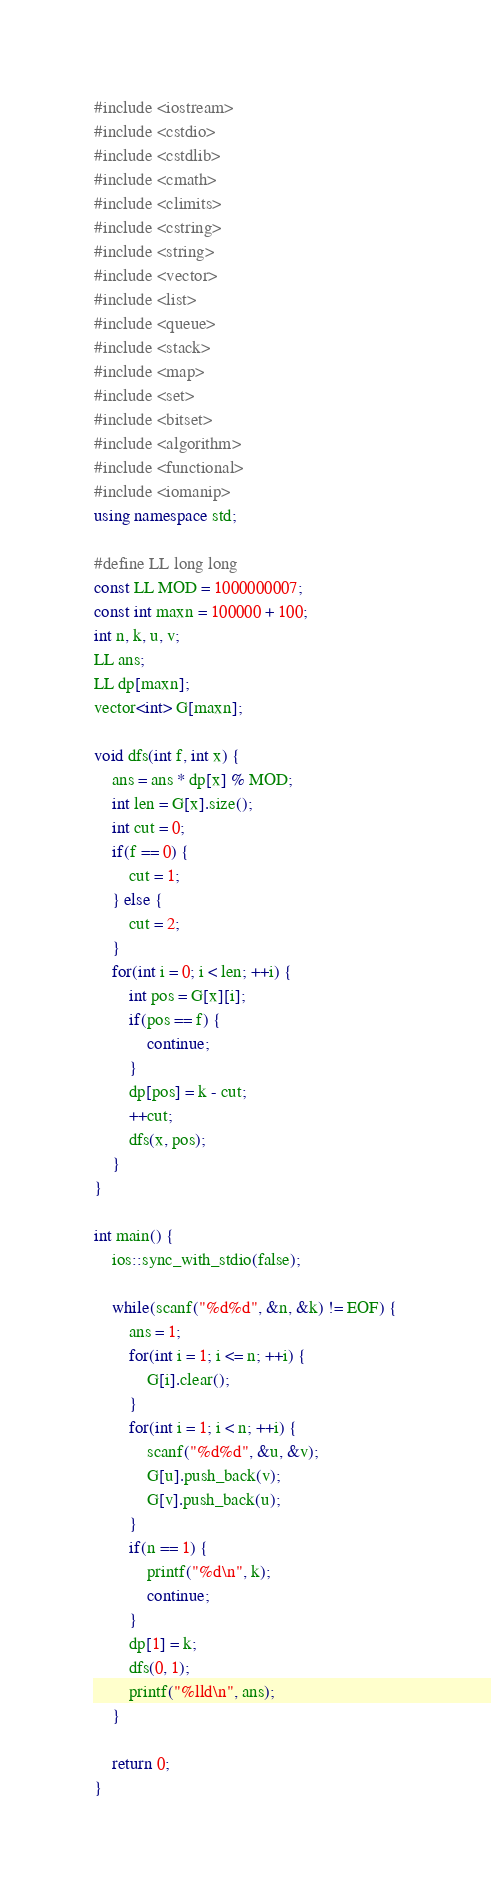Convert code to text. <code><loc_0><loc_0><loc_500><loc_500><_C++_>#include <iostream>
#include <cstdio>
#include <cstdlib>
#include <cmath>
#include <climits>
#include <cstring>
#include <string>
#include <vector>
#include <list>
#include <queue>
#include <stack>
#include <map>
#include <set>
#include <bitset>
#include <algorithm>
#include <functional>
#include <iomanip>
using namespace std;

#define LL long long
const LL MOD = 1000000007;
const int maxn = 100000 + 100;
int n, k, u, v;
LL ans;
LL dp[maxn];
vector<int> G[maxn];

void dfs(int f, int x) {
    ans = ans * dp[x] % MOD;
    int len = G[x].size();
    int cut = 0;
    if(f == 0) {
        cut = 1;
    } else {
        cut = 2;
    }
    for(int i = 0; i < len; ++i) {
        int pos = G[x][i];
        if(pos == f) {
            continue;
        }
        dp[pos] = k - cut;
        ++cut;
        dfs(x, pos);
    }
}

int main() {
    ios::sync_with_stdio(false);

    while(scanf("%d%d", &n, &k) != EOF) {
        ans = 1;
        for(int i = 1; i <= n; ++i) {
            G[i].clear();
        }
        for(int i = 1; i < n; ++i) {
            scanf("%d%d", &u, &v);
            G[u].push_back(v);
            G[v].push_back(u);
        }
        if(n == 1) {
            printf("%d\n", k);
            continue;
        }
        dp[1] = k;
        dfs(0, 1);
        printf("%lld\n", ans);
    }

    return 0;
}</code> 